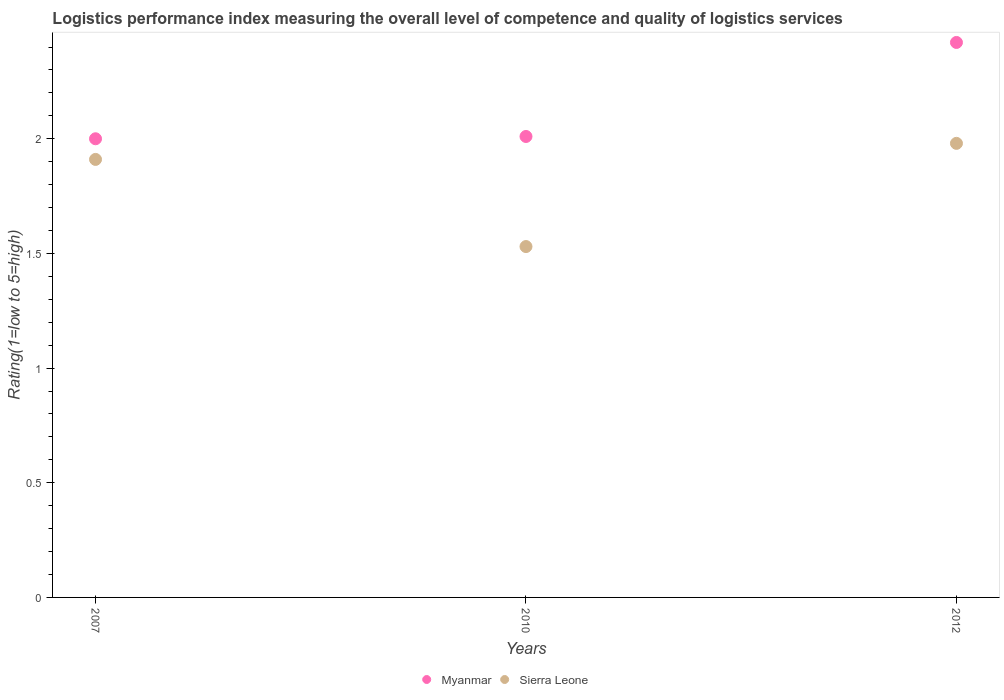Is the number of dotlines equal to the number of legend labels?
Provide a succinct answer. Yes. What is the Logistic performance index in Myanmar in 2012?
Provide a succinct answer. 2.42. Across all years, what is the maximum Logistic performance index in Myanmar?
Offer a very short reply. 2.42. Across all years, what is the minimum Logistic performance index in Myanmar?
Provide a short and direct response. 2. In which year was the Logistic performance index in Sierra Leone maximum?
Ensure brevity in your answer.  2012. What is the total Logistic performance index in Sierra Leone in the graph?
Your answer should be compact. 5.42. What is the difference between the Logistic performance index in Sierra Leone in 2007 and that in 2010?
Your answer should be very brief. 0.38. What is the difference between the Logistic performance index in Myanmar in 2010 and the Logistic performance index in Sierra Leone in 2012?
Give a very brief answer. 0.03. What is the average Logistic performance index in Sierra Leone per year?
Ensure brevity in your answer.  1.81. In the year 2010, what is the difference between the Logistic performance index in Myanmar and Logistic performance index in Sierra Leone?
Your answer should be very brief. 0.48. In how many years, is the Logistic performance index in Sierra Leone greater than 0.30000000000000004?
Offer a very short reply. 3. What is the ratio of the Logistic performance index in Sierra Leone in 2010 to that in 2012?
Make the answer very short. 0.77. What is the difference between the highest and the second highest Logistic performance index in Myanmar?
Give a very brief answer. 0.41. What is the difference between the highest and the lowest Logistic performance index in Myanmar?
Your response must be concise. 0.42. Is the Logistic performance index in Sierra Leone strictly greater than the Logistic performance index in Myanmar over the years?
Your response must be concise. No. Is the Logistic performance index in Myanmar strictly less than the Logistic performance index in Sierra Leone over the years?
Offer a terse response. No. What is the difference between two consecutive major ticks on the Y-axis?
Keep it short and to the point. 0.5. Are the values on the major ticks of Y-axis written in scientific E-notation?
Ensure brevity in your answer.  No. Does the graph contain grids?
Offer a terse response. No. How many legend labels are there?
Provide a short and direct response. 2. How are the legend labels stacked?
Make the answer very short. Horizontal. What is the title of the graph?
Give a very brief answer. Logistics performance index measuring the overall level of competence and quality of logistics services. Does "Uzbekistan" appear as one of the legend labels in the graph?
Offer a very short reply. No. What is the label or title of the X-axis?
Make the answer very short. Years. What is the label or title of the Y-axis?
Your response must be concise. Rating(1=low to 5=high). What is the Rating(1=low to 5=high) of Myanmar in 2007?
Your answer should be compact. 2. What is the Rating(1=low to 5=high) in Sierra Leone in 2007?
Offer a terse response. 1.91. What is the Rating(1=low to 5=high) of Myanmar in 2010?
Your response must be concise. 2.01. What is the Rating(1=low to 5=high) in Sierra Leone in 2010?
Make the answer very short. 1.53. What is the Rating(1=low to 5=high) in Myanmar in 2012?
Your response must be concise. 2.42. What is the Rating(1=low to 5=high) of Sierra Leone in 2012?
Provide a succinct answer. 1.98. Across all years, what is the maximum Rating(1=low to 5=high) of Myanmar?
Offer a terse response. 2.42. Across all years, what is the maximum Rating(1=low to 5=high) of Sierra Leone?
Ensure brevity in your answer.  1.98. Across all years, what is the minimum Rating(1=low to 5=high) of Myanmar?
Your response must be concise. 2. Across all years, what is the minimum Rating(1=low to 5=high) of Sierra Leone?
Your answer should be very brief. 1.53. What is the total Rating(1=low to 5=high) in Myanmar in the graph?
Offer a very short reply. 6.43. What is the total Rating(1=low to 5=high) of Sierra Leone in the graph?
Give a very brief answer. 5.42. What is the difference between the Rating(1=low to 5=high) of Myanmar in 2007 and that in 2010?
Keep it short and to the point. -0.01. What is the difference between the Rating(1=low to 5=high) of Sierra Leone in 2007 and that in 2010?
Provide a short and direct response. 0.38. What is the difference between the Rating(1=low to 5=high) in Myanmar in 2007 and that in 2012?
Offer a terse response. -0.42. What is the difference between the Rating(1=low to 5=high) of Sierra Leone in 2007 and that in 2012?
Offer a very short reply. -0.07. What is the difference between the Rating(1=low to 5=high) of Myanmar in 2010 and that in 2012?
Your response must be concise. -0.41. What is the difference between the Rating(1=low to 5=high) in Sierra Leone in 2010 and that in 2012?
Ensure brevity in your answer.  -0.45. What is the difference between the Rating(1=low to 5=high) in Myanmar in 2007 and the Rating(1=low to 5=high) in Sierra Leone in 2010?
Your answer should be very brief. 0.47. What is the difference between the Rating(1=low to 5=high) of Myanmar in 2010 and the Rating(1=low to 5=high) of Sierra Leone in 2012?
Your response must be concise. 0.03. What is the average Rating(1=low to 5=high) of Myanmar per year?
Make the answer very short. 2.14. What is the average Rating(1=low to 5=high) in Sierra Leone per year?
Give a very brief answer. 1.81. In the year 2007, what is the difference between the Rating(1=low to 5=high) of Myanmar and Rating(1=low to 5=high) of Sierra Leone?
Ensure brevity in your answer.  0.09. In the year 2010, what is the difference between the Rating(1=low to 5=high) in Myanmar and Rating(1=low to 5=high) in Sierra Leone?
Offer a terse response. 0.48. In the year 2012, what is the difference between the Rating(1=low to 5=high) in Myanmar and Rating(1=low to 5=high) in Sierra Leone?
Your answer should be compact. 0.44. What is the ratio of the Rating(1=low to 5=high) in Sierra Leone in 2007 to that in 2010?
Provide a succinct answer. 1.25. What is the ratio of the Rating(1=low to 5=high) of Myanmar in 2007 to that in 2012?
Provide a succinct answer. 0.83. What is the ratio of the Rating(1=low to 5=high) of Sierra Leone in 2007 to that in 2012?
Ensure brevity in your answer.  0.96. What is the ratio of the Rating(1=low to 5=high) of Myanmar in 2010 to that in 2012?
Offer a very short reply. 0.83. What is the ratio of the Rating(1=low to 5=high) of Sierra Leone in 2010 to that in 2012?
Offer a very short reply. 0.77. What is the difference between the highest and the second highest Rating(1=low to 5=high) of Myanmar?
Your answer should be compact. 0.41. What is the difference between the highest and the second highest Rating(1=low to 5=high) of Sierra Leone?
Keep it short and to the point. 0.07. What is the difference between the highest and the lowest Rating(1=low to 5=high) in Myanmar?
Your response must be concise. 0.42. What is the difference between the highest and the lowest Rating(1=low to 5=high) of Sierra Leone?
Your response must be concise. 0.45. 